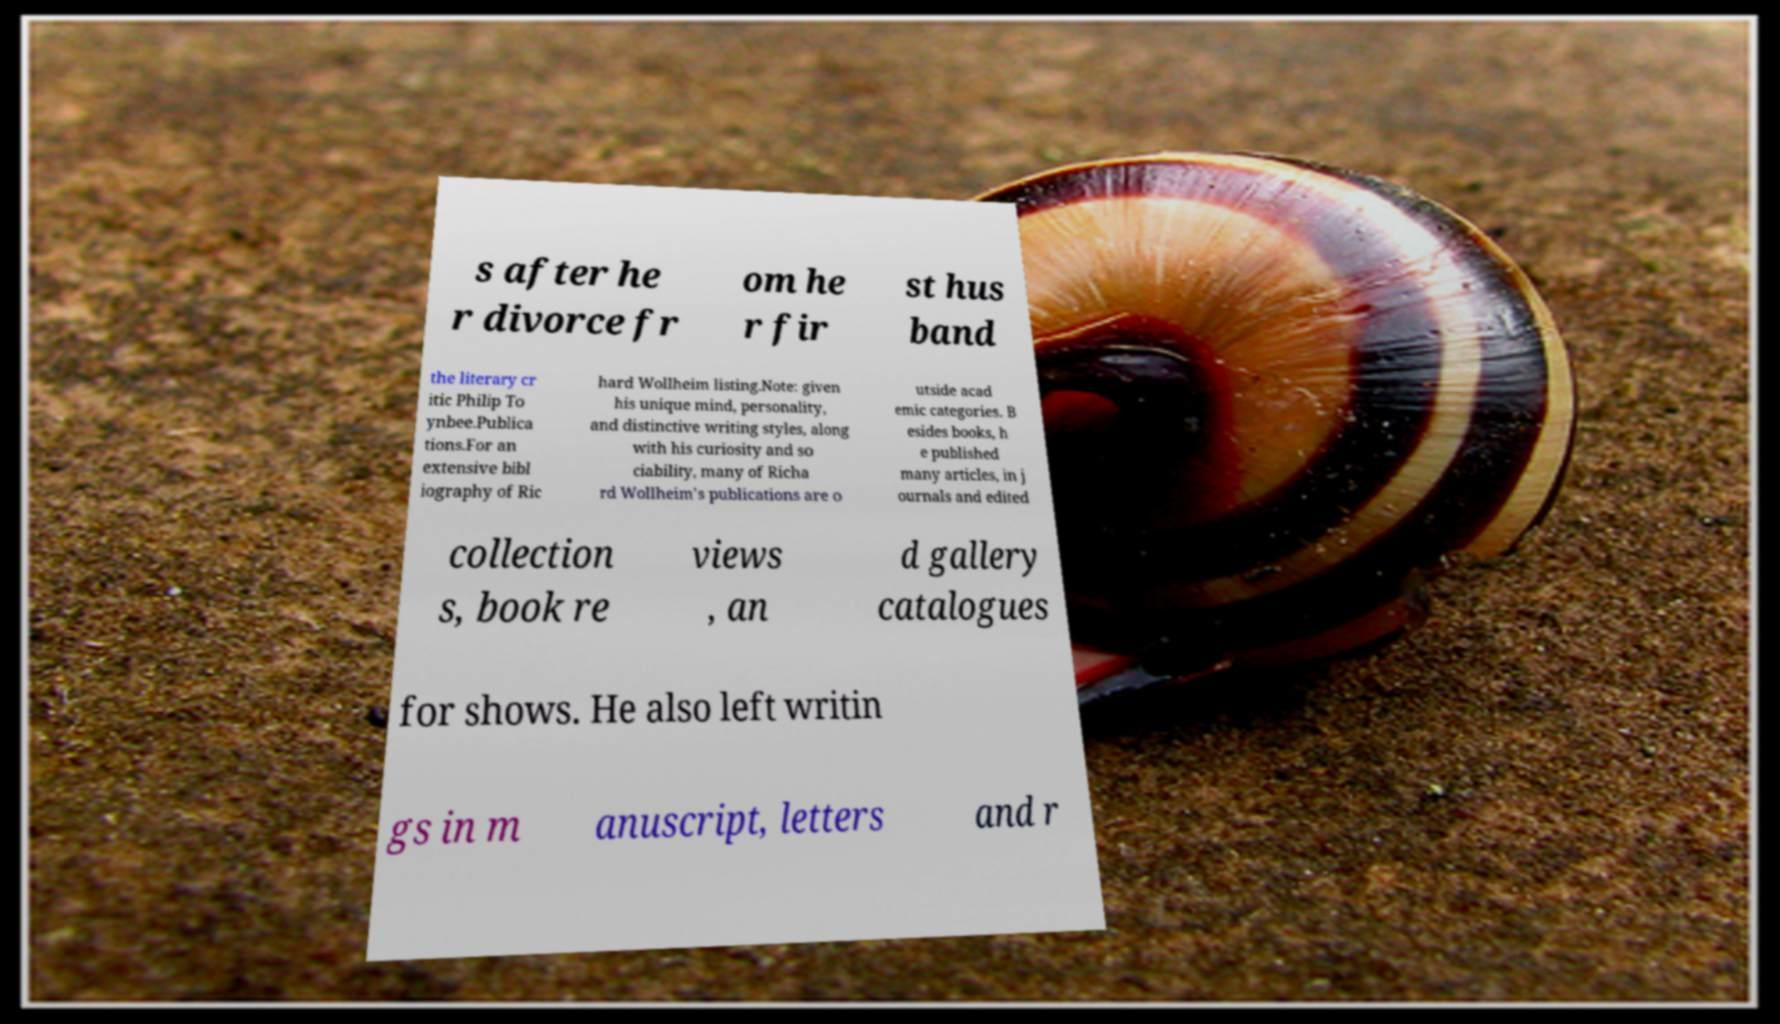There's text embedded in this image that I need extracted. Can you transcribe it verbatim? s after he r divorce fr om he r fir st hus band the literary cr itic Philip To ynbee.Publica tions.For an extensive bibl iography of Ric hard Wollheim listing.Note: given his unique mind, personality, and distinctive writing styles, along with his curiosity and so ciability, many of Richa rd Wollheim's publications are o utside acad emic categories. B esides books, h e published many articles, in j ournals and edited collection s, book re views , an d gallery catalogues for shows. He also left writin gs in m anuscript, letters and r 